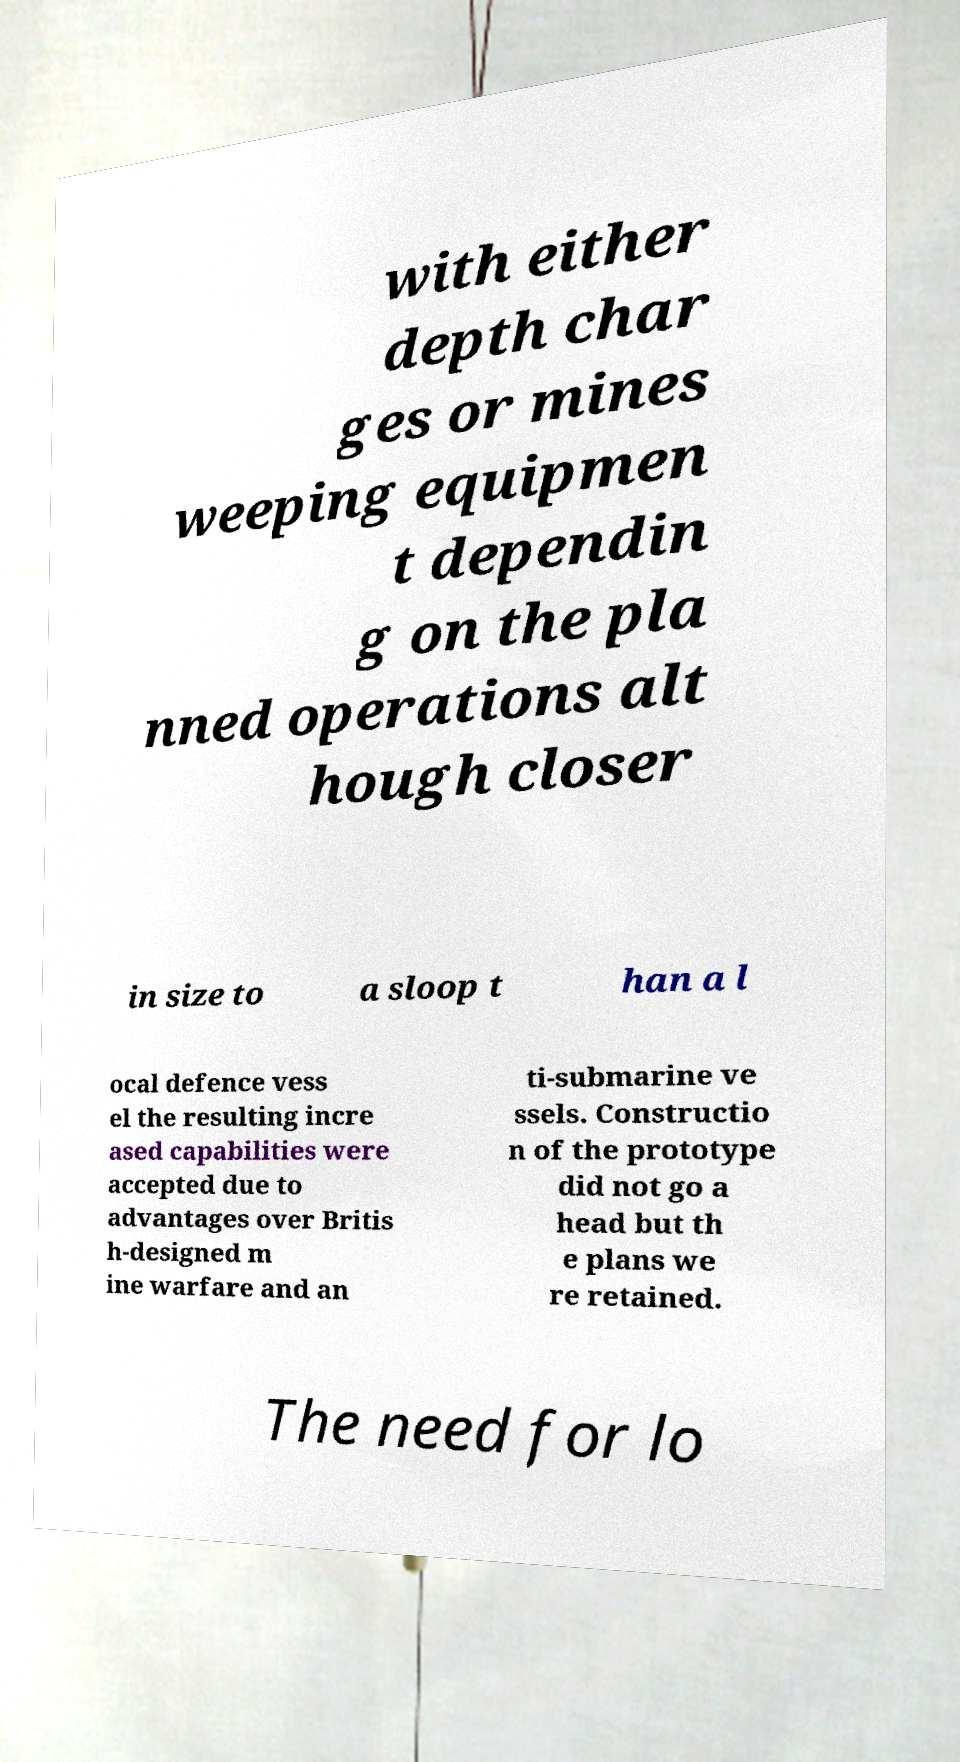Can you read and provide the text displayed in the image?This photo seems to have some interesting text. Can you extract and type it out for me? with either depth char ges or mines weeping equipmen t dependin g on the pla nned operations alt hough closer in size to a sloop t han a l ocal defence vess el the resulting incre ased capabilities were accepted due to advantages over Britis h-designed m ine warfare and an ti-submarine ve ssels. Constructio n of the prototype did not go a head but th e plans we re retained. The need for lo 